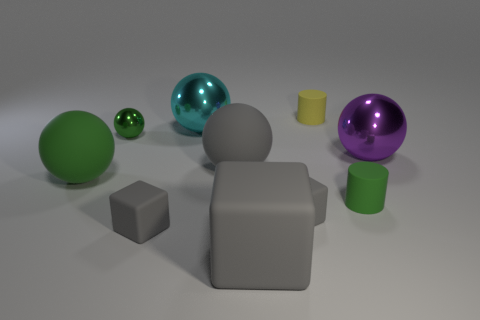How does the lighting in the scene affect the appearance of the objects? The lighting in the scene casts soft shadows and gives a subtle gloss to the metallic spheres, enhancing the three-dimensional feel of the objects. 